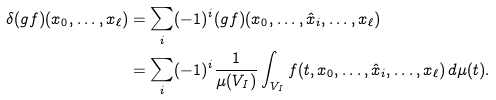Convert formula to latex. <formula><loc_0><loc_0><loc_500><loc_500>\delta ( g f ) ( x _ { 0 } , \dots , x _ { \ell } ) & = \sum _ { i } ( - 1 ) ^ { i } ( g f ) ( x _ { 0 } , \dots , \hat { x } _ { i } , \dots , x _ { \ell } ) \\ & = \sum _ { i } ( - 1 ) ^ { i } \frac { 1 } { \mu ( V _ { I } ) } \int _ { V _ { I } } f ( t , x _ { 0 } , \dots , \hat { x } _ { i } , \dots , x _ { \ell } ) \, d \mu ( t ) .</formula> 